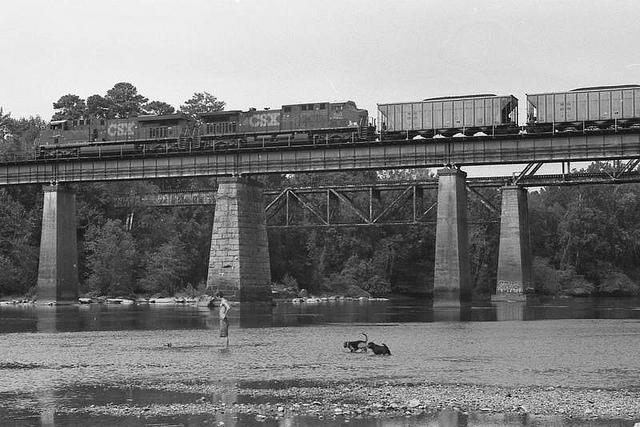Why is the train on a bridge?

Choices:
A) crossing river
B) stolen
C) is broken
D) lost crossing river 